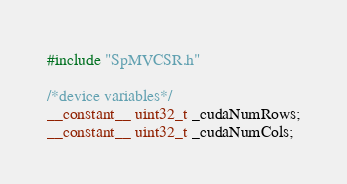<code> <loc_0><loc_0><loc_500><loc_500><_Cuda_>#include "SpMVCSR.h"

/*device variables*/
__constant__ uint32_t _cudaNumRows;
__constant__ uint32_t _cudaNumCols;

</code> 